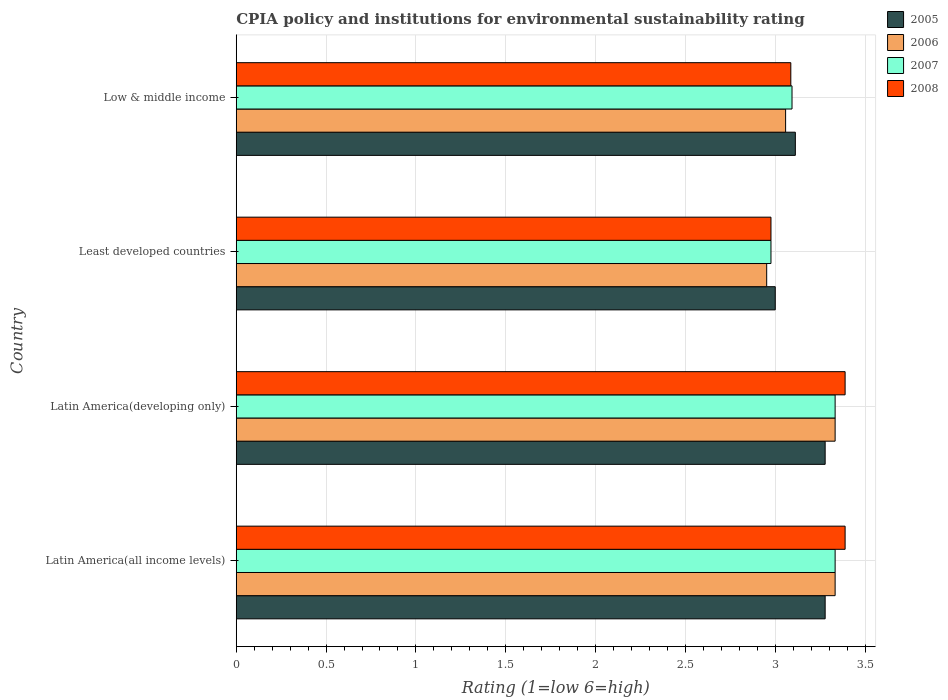How many different coloured bars are there?
Provide a succinct answer. 4. How many groups of bars are there?
Offer a very short reply. 4. How many bars are there on the 2nd tick from the top?
Ensure brevity in your answer.  4. How many bars are there on the 4th tick from the bottom?
Make the answer very short. 4. What is the label of the 3rd group of bars from the top?
Your answer should be very brief. Latin America(developing only). In how many cases, is the number of bars for a given country not equal to the number of legend labels?
Ensure brevity in your answer.  0. What is the CPIA rating in 2005 in Low & middle income?
Give a very brief answer. 3.11. Across all countries, what is the maximum CPIA rating in 2007?
Keep it short and to the point. 3.33. In which country was the CPIA rating in 2005 maximum?
Keep it short and to the point. Latin America(all income levels). In which country was the CPIA rating in 2005 minimum?
Provide a succinct answer. Least developed countries. What is the total CPIA rating in 2006 in the graph?
Keep it short and to the point. 12.68. What is the difference between the CPIA rating in 2007 in Latin America(developing only) and that in Low & middle income?
Offer a terse response. 0.24. What is the difference between the CPIA rating in 2007 in Latin America(all income levels) and the CPIA rating in 2008 in Low & middle income?
Give a very brief answer. 0.25. What is the average CPIA rating in 2006 per country?
Your response must be concise. 3.17. What is the difference between the CPIA rating in 2006 and CPIA rating in 2008 in Latin America(developing only)?
Your answer should be compact. -0.06. What is the ratio of the CPIA rating in 2006 in Latin America(all income levels) to that in Low & middle income?
Your answer should be very brief. 1.09. What is the difference between the highest and the second highest CPIA rating in 2008?
Make the answer very short. 0. What is the difference between the highest and the lowest CPIA rating in 2005?
Provide a short and direct response. 0.28. In how many countries, is the CPIA rating in 2006 greater than the average CPIA rating in 2006 taken over all countries?
Provide a succinct answer. 2. What does the 3rd bar from the bottom in Latin America(developing only) represents?
Provide a succinct answer. 2007. Does the graph contain any zero values?
Make the answer very short. No. Does the graph contain grids?
Offer a very short reply. Yes. What is the title of the graph?
Keep it short and to the point. CPIA policy and institutions for environmental sustainability rating. What is the label or title of the X-axis?
Make the answer very short. Rating (1=low 6=high). What is the label or title of the Y-axis?
Your response must be concise. Country. What is the Rating (1=low 6=high) of 2005 in Latin America(all income levels)?
Make the answer very short. 3.28. What is the Rating (1=low 6=high) in 2006 in Latin America(all income levels)?
Ensure brevity in your answer.  3.33. What is the Rating (1=low 6=high) in 2007 in Latin America(all income levels)?
Your answer should be very brief. 3.33. What is the Rating (1=low 6=high) in 2008 in Latin America(all income levels)?
Offer a terse response. 3.39. What is the Rating (1=low 6=high) of 2005 in Latin America(developing only)?
Offer a very short reply. 3.28. What is the Rating (1=low 6=high) of 2006 in Latin America(developing only)?
Offer a terse response. 3.33. What is the Rating (1=low 6=high) in 2007 in Latin America(developing only)?
Your response must be concise. 3.33. What is the Rating (1=low 6=high) in 2008 in Latin America(developing only)?
Ensure brevity in your answer.  3.39. What is the Rating (1=low 6=high) of 2005 in Least developed countries?
Offer a terse response. 3. What is the Rating (1=low 6=high) in 2006 in Least developed countries?
Ensure brevity in your answer.  2.95. What is the Rating (1=low 6=high) in 2007 in Least developed countries?
Offer a terse response. 2.98. What is the Rating (1=low 6=high) of 2008 in Least developed countries?
Keep it short and to the point. 2.98. What is the Rating (1=low 6=high) in 2005 in Low & middle income?
Provide a succinct answer. 3.11. What is the Rating (1=low 6=high) of 2006 in Low & middle income?
Provide a short and direct response. 3.06. What is the Rating (1=low 6=high) of 2007 in Low & middle income?
Your answer should be very brief. 3.09. What is the Rating (1=low 6=high) in 2008 in Low & middle income?
Offer a terse response. 3.09. Across all countries, what is the maximum Rating (1=low 6=high) in 2005?
Your response must be concise. 3.28. Across all countries, what is the maximum Rating (1=low 6=high) in 2006?
Keep it short and to the point. 3.33. Across all countries, what is the maximum Rating (1=low 6=high) of 2007?
Make the answer very short. 3.33. Across all countries, what is the maximum Rating (1=low 6=high) in 2008?
Your answer should be compact. 3.39. Across all countries, what is the minimum Rating (1=low 6=high) of 2006?
Offer a terse response. 2.95. Across all countries, what is the minimum Rating (1=low 6=high) of 2007?
Ensure brevity in your answer.  2.98. Across all countries, what is the minimum Rating (1=low 6=high) of 2008?
Provide a short and direct response. 2.98. What is the total Rating (1=low 6=high) of 2005 in the graph?
Offer a very short reply. 12.67. What is the total Rating (1=low 6=high) in 2006 in the graph?
Give a very brief answer. 12.68. What is the total Rating (1=low 6=high) in 2007 in the graph?
Offer a terse response. 12.74. What is the total Rating (1=low 6=high) in 2008 in the graph?
Offer a very short reply. 12.84. What is the difference between the Rating (1=low 6=high) in 2005 in Latin America(all income levels) and that in Latin America(developing only)?
Provide a succinct answer. 0. What is the difference between the Rating (1=low 6=high) of 2008 in Latin America(all income levels) and that in Latin America(developing only)?
Make the answer very short. 0. What is the difference between the Rating (1=low 6=high) of 2005 in Latin America(all income levels) and that in Least developed countries?
Your response must be concise. 0.28. What is the difference between the Rating (1=low 6=high) in 2006 in Latin America(all income levels) and that in Least developed countries?
Your response must be concise. 0.38. What is the difference between the Rating (1=low 6=high) of 2007 in Latin America(all income levels) and that in Least developed countries?
Offer a terse response. 0.36. What is the difference between the Rating (1=low 6=high) in 2008 in Latin America(all income levels) and that in Least developed countries?
Make the answer very short. 0.41. What is the difference between the Rating (1=low 6=high) of 2005 in Latin America(all income levels) and that in Low & middle income?
Make the answer very short. 0.17. What is the difference between the Rating (1=low 6=high) in 2006 in Latin America(all income levels) and that in Low & middle income?
Ensure brevity in your answer.  0.28. What is the difference between the Rating (1=low 6=high) in 2007 in Latin America(all income levels) and that in Low & middle income?
Make the answer very short. 0.24. What is the difference between the Rating (1=low 6=high) in 2008 in Latin America(all income levels) and that in Low & middle income?
Give a very brief answer. 0.3. What is the difference between the Rating (1=low 6=high) in 2005 in Latin America(developing only) and that in Least developed countries?
Offer a terse response. 0.28. What is the difference between the Rating (1=low 6=high) in 2006 in Latin America(developing only) and that in Least developed countries?
Provide a short and direct response. 0.38. What is the difference between the Rating (1=low 6=high) of 2007 in Latin America(developing only) and that in Least developed countries?
Make the answer very short. 0.36. What is the difference between the Rating (1=low 6=high) in 2008 in Latin America(developing only) and that in Least developed countries?
Ensure brevity in your answer.  0.41. What is the difference between the Rating (1=low 6=high) in 2005 in Latin America(developing only) and that in Low & middle income?
Your response must be concise. 0.17. What is the difference between the Rating (1=low 6=high) of 2006 in Latin America(developing only) and that in Low & middle income?
Provide a short and direct response. 0.28. What is the difference between the Rating (1=low 6=high) in 2007 in Latin America(developing only) and that in Low & middle income?
Keep it short and to the point. 0.24. What is the difference between the Rating (1=low 6=high) in 2008 in Latin America(developing only) and that in Low & middle income?
Give a very brief answer. 0.3. What is the difference between the Rating (1=low 6=high) of 2005 in Least developed countries and that in Low & middle income?
Your response must be concise. -0.11. What is the difference between the Rating (1=low 6=high) of 2006 in Least developed countries and that in Low & middle income?
Provide a succinct answer. -0.11. What is the difference between the Rating (1=low 6=high) in 2007 in Least developed countries and that in Low & middle income?
Ensure brevity in your answer.  -0.12. What is the difference between the Rating (1=low 6=high) in 2008 in Least developed countries and that in Low & middle income?
Keep it short and to the point. -0.11. What is the difference between the Rating (1=low 6=high) in 2005 in Latin America(all income levels) and the Rating (1=low 6=high) in 2006 in Latin America(developing only)?
Your response must be concise. -0.06. What is the difference between the Rating (1=low 6=high) in 2005 in Latin America(all income levels) and the Rating (1=low 6=high) in 2007 in Latin America(developing only)?
Keep it short and to the point. -0.06. What is the difference between the Rating (1=low 6=high) in 2005 in Latin America(all income levels) and the Rating (1=low 6=high) in 2008 in Latin America(developing only)?
Provide a short and direct response. -0.11. What is the difference between the Rating (1=low 6=high) in 2006 in Latin America(all income levels) and the Rating (1=low 6=high) in 2007 in Latin America(developing only)?
Give a very brief answer. 0. What is the difference between the Rating (1=low 6=high) of 2006 in Latin America(all income levels) and the Rating (1=low 6=high) of 2008 in Latin America(developing only)?
Offer a very short reply. -0.06. What is the difference between the Rating (1=low 6=high) of 2007 in Latin America(all income levels) and the Rating (1=low 6=high) of 2008 in Latin America(developing only)?
Ensure brevity in your answer.  -0.06. What is the difference between the Rating (1=low 6=high) of 2005 in Latin America(all income levels) and the Rating (1=low 6=high) of 2006 in Least developed countries?
Your answer should be compact. 0.33. What is the difference between the Rating (1=low 6=high) in 2005 in Latin America(all income levels) and the Rating (1=low 6=high) in 2007 in Least developed countries?
Ensure brevity in your answer.  0.3. What is the difference between the Rating (1=low 6=high) of 2005 in Latin America(all income levels) and the Rating (1=low 6=high) of 2008 in Least developed countries?
Give a very brief answer. 0.3. What is the difference between the Rating (1=low 6=high) of 2006 in Latin America(all income levels) and the Rating (1=low 6=high) of 2007 in Least developed countries?
Provide a short and direct response. 0.36. What is the difference between the Rating (1=low 6=high) of 2006 in Latin America(all income levels) and the Rating (1=low 6=high) of 2008 in Least developed countries?
Keep it short and to the point. 0.36. What is the difference between the Rating (1=low 6=high) in 2007 in Latin America(all income levels) and the Rating (1=low 6=high) in 2008 in Least developed countries?
Ensure brevity in your answer.  0.36. What is the difference between the Rating (1=low 6=high) in 2005 in Latin America(all income levels) and the Rating (1=low 6=high) in 2006 in Low & middle income?
Your answer should be very brief. 0.22. What is the difference between the Rating (1=low 6=high) of 2005 in Latin America(all income levels) and the Rating (1=low 6=high) of 2007 in Low & middle income?
Give a very brief answer. 0.18. What is the difference between the Rating (1=low 6=high) in 2005 in Latin America(all income levels) and the Rating (1=low 6=high) in 2008 in Low & middle income?
Make the answer very short. 0.19. What is the difference between the Rating (1=low 6=high) of 2006 in Latin America(all income levels) and the Rating (1=low 6=high) of 2007 in Low & middle income?
Your answer should be very brief. 0.24. What is the difference between the Rating (1=low 6=high) of 2006 in Latin America(all income levels) and the Rating (1=low 6=high) of 2008 in Low & middle income?
Your answer should be very brief. 0.25. What is the difference between the Rating (1=low 6=high) in 2007 in Latin America(all income levels) and the Rating (1=low 6=high) in 2008 in Low & middle income?
Your answer should be very brief. 0.25. What is the difference between the Rating (1=low 6=high) in 2005 in Latin America(developing only) and the Rating (1=low 6=high) in 2006 in Least developed countries?
Give a very brief answer. 0.33. What is the difference between the Rating (1=low 6=high) of 2005 in Latin America(developing only) and the Rating (1=low 6=high) of 2007 in Least developed countries?
Give a very brief answer. 0.3. What is the difference between the Rating (1=low 6=high) of 2005 in Latin America(developing only) and the Rating (1=low 6=high) of 2008 in Least developed countries?
Ensure brevity in your answer.  0.3. What is the difference between the Rating (1=low 6=high) of 2006 in Latin America(developing only) and the Rating (1=low 6=high) of 2007 in Least developed countries?
Your response must be concise. 0.36. What is the difference between the Rating (1=low 6=high) of 2006 in Latin America(developing only) and the Rating (1=low 6=high) of 2008 in Least developed countries?
Your response must be concise. 0.36. What is the difference between the Rating (1=low 6=high) in 2007 in Latin America(developing only) and the Rating (1=low 6=high) in 2008 in Least developed countries?
Your answer should be very brief. 0.36. What is the difference between the Rating (1=low 6=high) in 2005 in Latin America(developing only) and the Rating (1=low 6=high) in 2006 in Low & middle income?
Offer a very short reply. 0.22. What is the difference between the Rating (1=low 6=high) in 2005 in Latin America(developing only) and the Rating (1=low 6=high) in 2007 in Low & middle income?
Your answer should be very brief. 0.18. What is the difference between the Rating (1=low 6=high) of 2005 in Latin America(developing only) and the Rating (1=low 6=high) of 2008 in Low & middle income?
Give a very brief answer. 0.19. What is the difference between the Rating (1=low 6=high) of 2006 in Latin America(developing only) and the Rating (1=low 6=high) of 2007 in Low & middle income?
Provide a succinct answer. 0.24. What is the difference between the Rating (1=low 6=high) in 2006 in Latin America(developing only) and the Rating (1=low 6=high) in 2008 in Low & middle income?
Keep it short and to the point. 0.25. What is the difference between the Rating (1=low 6=high) in 2007 in Latin America(developing only) and the Rating (1=low 6=high) in 2008 in Low & middle income?
Ensure brevity in your answer.  0.25. What is the difference between the Rating (1=low 6=high) of 2005 in Least developed countries and the Rating (1=low 6=high) of 2006 in Low & middle income?
Ensure brevity in your answer.  -0.06. What is the difference between the Rating (1=low 6=high) in 2005 in Least developed countries and the Rating (1=low 6=high) in 2007 in Low & middle income?
Your response must be concise. -0.09. What is the difference between the Rating (1=low 6=high) in 2005 in Least developed countries and the Rating (1=low 6=high) in 2008 in Low & middle income?
Offer a terse response. -0.09. What is the difference between the Rating (1=low 6=high) in 2006 in Least developed countries and the Rating (1=low 6=high) in 2007 in Low & middle income?
Your answer should be compact. -0.14. What is the difference between the Rating (1=low 6=high) in 2006 in Least developed countries and the Rating (1=low 6=high) in 2008 in Low & middle income?
Offer a very short reply. -0.13. What is the difference between the Rating (1=low 6=high) of 2007 in Least developed countries and the Rating (1=low 6=high) of 2008 in Low & middle income?
Your answer should be compact. -0.11. What is the average Rating (1=low 6=high) in 2005 per country?
Keep it short and to the point. 3.17. What is the average Rating (1=low 6=high) of 2006 per country?
Offer a terse response. 3.17. What is the average Rating (1=low 6=high) of 2007 per country?
Make the answer very short. 3.18. What is the average Rating (1=low 6=high) in 2008 per country?
Give a very brief answer. 3.21. What is the difference between the Rating (1=low 6=high) in 2005 and Rating (1=low 6=high) in 2006 in Latin America(all income levels)?
Provide a succinct answer. -0.06. What is the difference between the Rating (1=low 6=high) in 2005 and Rating (1=low 6=high) in 2007 in Latin America(all income levels)?
Give a very brief answer. -0.06. What is the difference between the Rating (1=low 6=high) of 2005 and Rating (1=low 6=high) of 2008 in Latin America(all income levels)?
Your answer should be very brief. -0.11. What is the difference between the Rating (1=low 6=high) of 2006 and Rating (1=low 6=high) of 2008 in Latin America(all income levels)?
Offer a very short reply. -0.06. What is the difference between the Rating (1=low 6=high) of 2007 and Rating (1=low 6=high) of 2008 in Latin America(all income levels)?
Keep it short and to the point. -0.06. What is the difference between the Rating (1=low 6=high) of 2005 and Rating (1=low 6=high) of 2006 in Latin America(developing only)?
Offer a terse response. -0.06. What is the difference between the Rating (1=low 6=high) of 2005 and Rating (1=low 6=high) of 2007 in Latin America(developing only)?
Provide a short and direct response. -0.06. What is the difference between the Rating (1=low 6=high) of 2005 and Rating (1=low 6=high) of 2008 in Latin America(developing only)?
Give a very brief answer. -0.11. What is the difference between the Rating (1=low 6=high) in 2006 and Rating (1=low 6=high) in 2007 in Latin America(developing only)?
Your answer should be compact. 0. What is the difference between the Rating (1=low 6=high) in 2006 and Rating (1=low 6=high) in 2008 in Latin America(developing only)?
Provide a short and direct response. -0.06. What is the difference between the Rating (1=low 6=high) in 2007 and Rating (1=low 6=high) in 2008 in Latin America(developing only)?
Your answer should be very brief. -0.06. What is the difference between the Rating (1=low 6=high) of 2005 and Rating (1=low 6=high) of 2006 in Least developed countries?
Give a very brief answer. 0.05. What is the difference between the Rating (1=low 6=high) of 2005 and Rating (1=low 6=high) of 2007 in Least developed countries?
Provide a short and direct response. 0.02. What is the difference between the Rating (1=low 6=high) in 2005 and Rating (1=low 6=high) in 2008 in Least developed countries?
Your response must be concise. 0.02. What is the difference between the Rating (1=low 6=high) in 2006 and Rating (1=low 6=high) in 2007 in Least developed countries?
Ensure brevity in your answer.  -0.02. What is the difference between the Rating (1=low 6=high) of 2006 and Rating (1=low 6=high) of 2008 in Least developed countries?
Provide a short and direct response. -0.02. What is the difference between the Rating (1=low 6=high) of 2005 and Rating (1=low 6=high) of 2006 in Low & middle income?
Give a very brief answer. 0.05. What is the difference between the Rating (1=low 6=high) in 2005 and Rating (1=low 6=high) in 2007 in Low & middle income?
Provide a short and direct response. 0.02. What is the difference between the Rating (1=low 6=high) in 2005 and Rating (1=low 6=high) in 2008 in Low & middle income?
Provide a short and direct response. 0.03. What is the difference between the Rating (1=low 6=high) of 2006 and Rating (1=low 6=high) of 2007 in Low & middle income?
Keep it short and to the point. -0.04. What is the difference between the Rating (1=low 6=high) in 2006 and Rating (1=low 6=high) in 2008 in Low & middle income?
Offer a terse response. -0.03. What is the difference between the Rating (1=low 6=high) in 2007 and Rating (1=low 6=high) in 2008 in Low & middle income?
Make the answer very short. 0.01. What is the ratio of the Rating (1=low 6=high) of 2006 in Latin America(all income levels) to that in Latin America(developing only)?
Provide a succinct answer. 1. What is the ratio of the Rating (1=low 6=high) of 2005 in Latin America(all income levels) to that in Least developed countries?
Offer a terse response. 1.09. What is the ratio of the Rating (1=low 6=high) of 2006 in Latin America(all income levels) to that in Least developed countries?
Provide a short and direct response. 1.13. What is the ratio of the Rating (1=low 6=high) of 2007 in Latin America(all income levels) to that in Least developed countries?
Your response must be concise. 1.12. What is the ratio of the Rating (1=low 6=high) in 2008 in Latin America(all income levels) to that in Least developed countries?
Ensure brevity in your answer.  1.14. What is the ratio of the Rating (1=low 6=high) of 2005 in Latin America(all income levels) to that in Low & middle income?
Provide a short and direct response. 1.05. What is the ratio of the Rating (1=low 6=high) in 2006 in Latin America(all income levels) to that in Low & middle income?
Offer a very short reply. 1.09. What is the ratio of the Rating (1=low 6=high) in 2007 in Latin America(all income levels) to that in Low & middle income?
Your answer should be compact. 1.08. What is the ratio of the Rating (1=low 6=high) in 2008 in Latin America(all income levels) to that in Low & middle income?
Ensure brevity in your answer.  1.1. What is the ratio of the Rating (1=low 6=high) of 2005 in Latin America(developing only) to that in Least developed countries?
Give a very brief answer. 1.09. What is the ratio of the Rating (1=low 6=high) of 2006 in Latin America(developing only) to that in Least developed countries?
Provide a succinct answer. 1.13. What is the ratio of the Rating (1=low 6=high) in 2007 in Latin America(developing only) to that in Least developed countries?
Give a very brief answer. 1.12. What is the ratio of the Rating (1=low 6=high) in 2008 in Latin America(developing only) to that in Least developed countries?
Provide a succinct answer. 1.14. What is the ratio of the Rating (1=low 6=high) in 2005 in Latin America(developing only) to that in Low & middle income?
Your answer should be compact. 1.05. What is the ratio of the Rating (1=low 6=high) in 2006 in Latin America(developing only) to that in Low & middle income?
Keep it short and to the point. 1.09. What is the ratio of the Rating (1=low 6=high) of 2007 in Latin America(developing only) to that in Low & middle income?
Keep it short and to the point. 1.08. What is the ratio of the Rating (1=low 6=high) of 2008 in Latin America(developing only) to that in Low & middle income?
Your response must be concise. 1.1. What is the ratio of the Rating (1=low 6=high) in 2005 in Least developed countries to that in Low & middle income?
Offer a terse response. 0.96. What is the ratio of the Rating (1=low 6=high) in 2006 in Least developed countries to that in Low & middle income?
Provide a short and direct response. 0.97. What is the ratio of the Rating (1=low 6=high) of 2007 in Least developed countries to that in Low & middle income?
Offer a terse response. 0.96. What is the ratio of the Rating (1=low 6=high) of 2008 in Least developed countries to that in Low & middle income?
Keep it short and to the point. 0.96. What is the difference between the highest and the second highest Rating (1=low 6=high) in 2006?
Provide a short and direct response. 0. What is the difference between the highest and the second highest Rating (1=low 6=high) of 2008?
Ensure brevity in your answer.  0. What is the difference between the highest and the lowest Rating (1=low 6=high) in 2005?
Make the answer very short. 0.28. What is the difference between the highest and the lowest Rating (1=low 6=high) in 2006?
Keep it short and to the point. 0.38. What is the difference between the highest and the lowest Rating (1=low 6=high) of 2007?
Your response must be concise. 0.36. What is the difference between the highest and the lowest Rating (1=low 6=high) in 2008?
Ensure brevity in your answer.  0.41. 